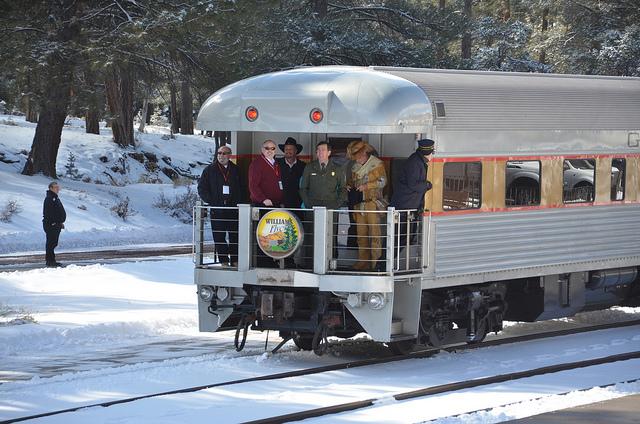Why are the people on the edge of the train?
Answer briefly. Sightseeing. Is there a man standing beside the train?
Be succinct. Yes. What job does the man NOT on the train have?
Concise answer only. Security. 